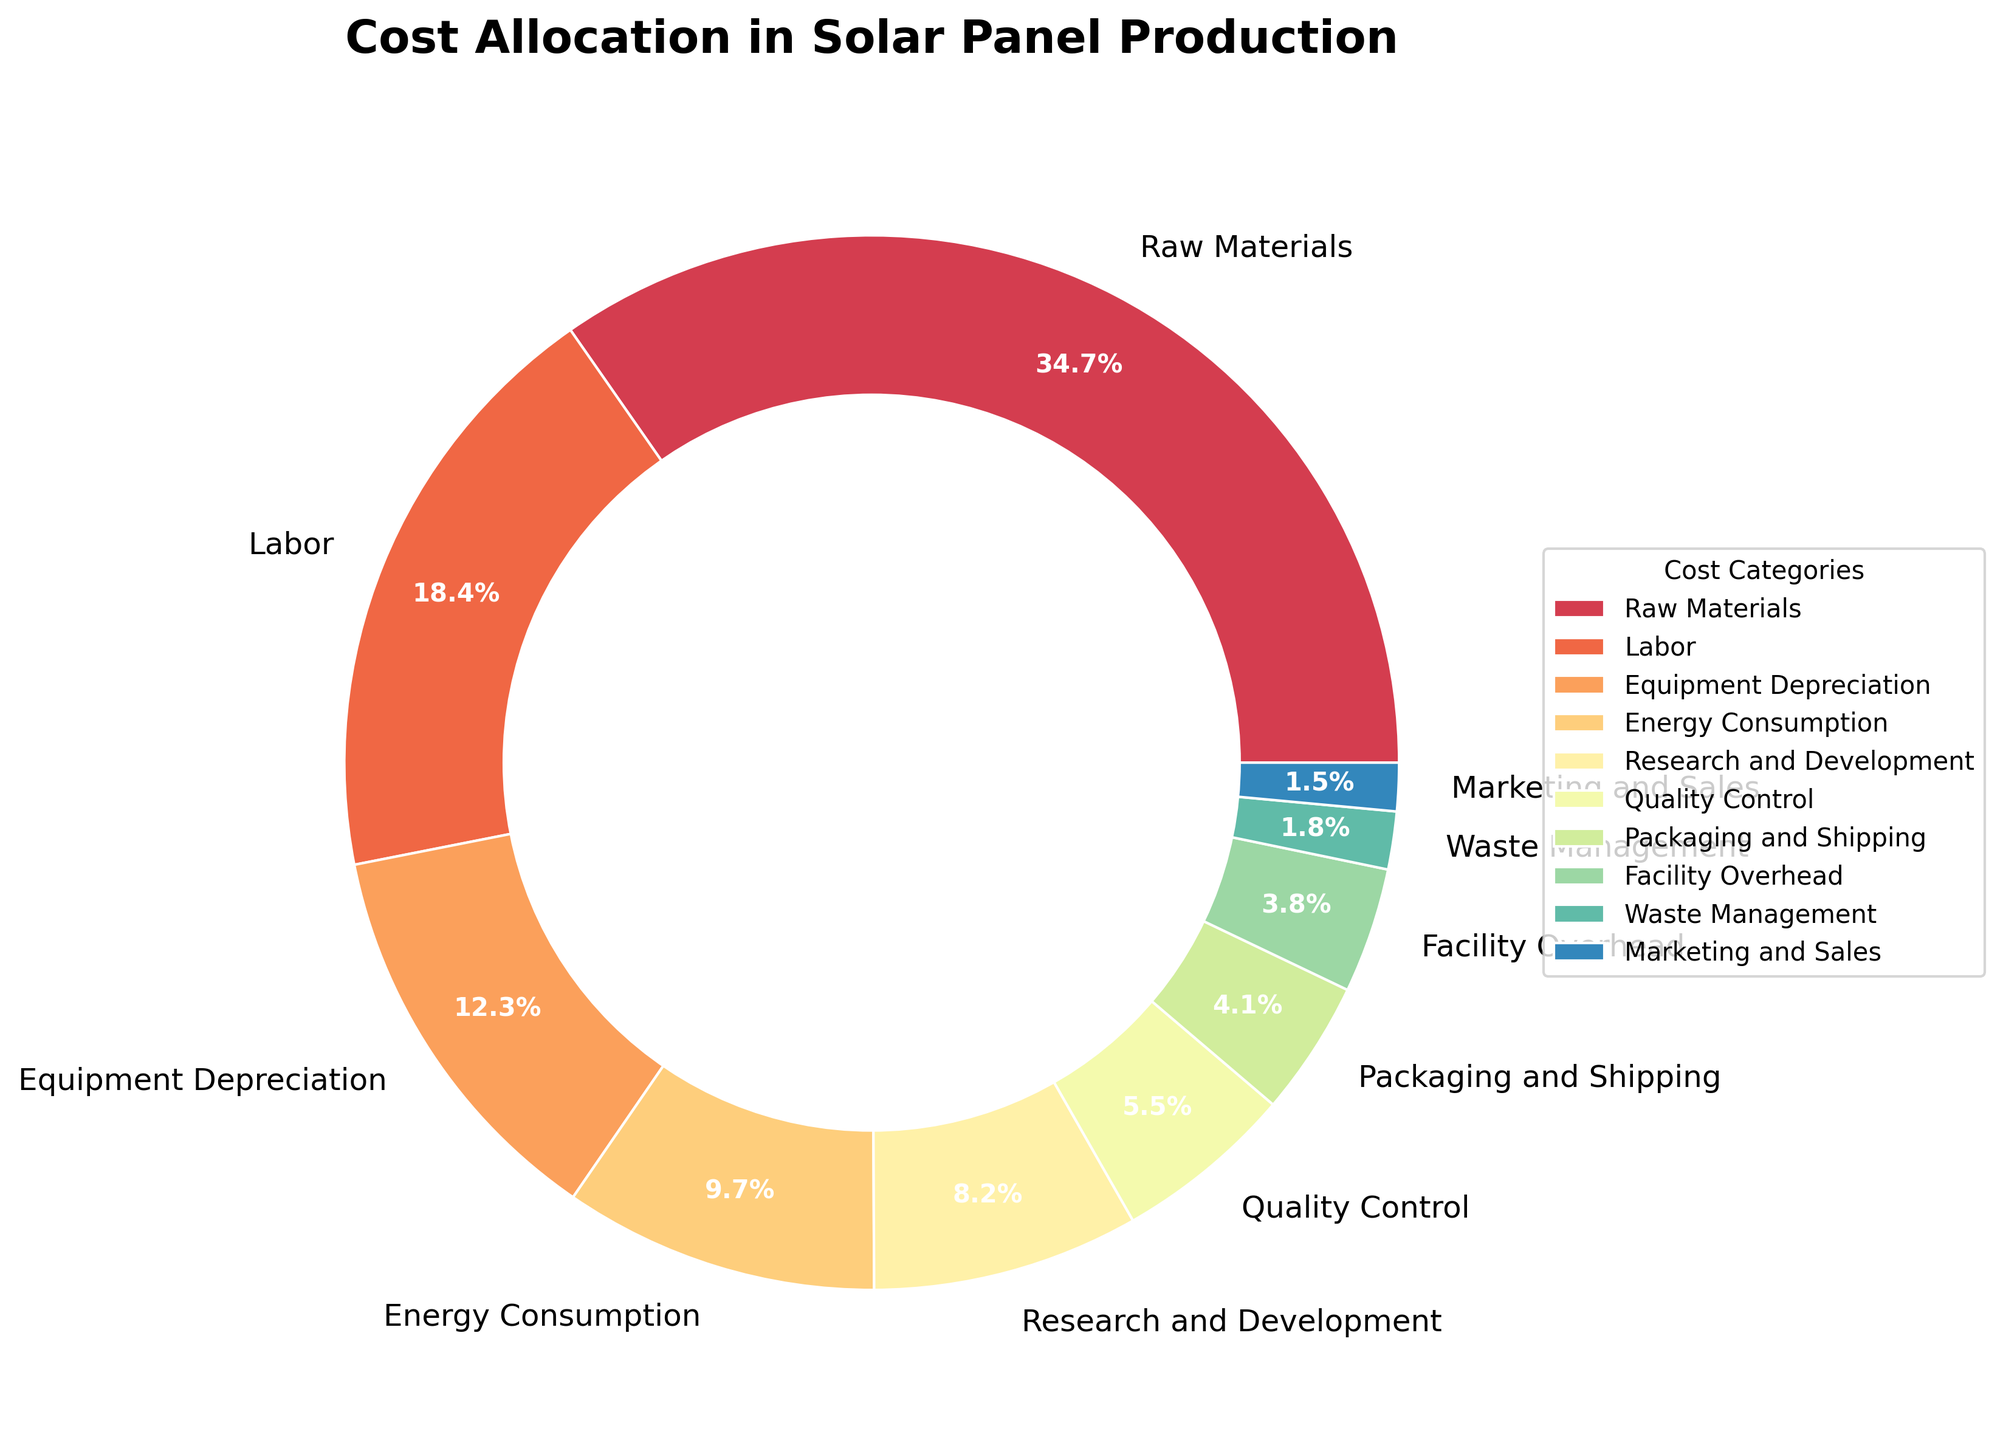What is the largest cost category in solar panel production? The slice representing "Raw Materials" is the largest in the pie chart. Its label indicates that it accounts for 35.2% of the total cost.
Answer: Raw Materials Which cost category has the smallest allocation? The slice labeled "Marketing and Sales" is the smallest, representing only 1.5% of the total cost.
Answer: Marketing and Sales What is the combined percentage of "Labor" and "Energy Consumption"? From the pie chart, "Labor" is 18.7% and "Energy Consumption" is 9.8%. Adding these two percentages gives 18.7 + 9.8 = 28.5%.
Answer: 28.5% How much more is spent on "Research and Development" compared to "Waste Management"? The chart shows "Research and Development" at 8.3% and "Waste Management" at 1.8%. The difference is 8.3 - 1.8 = 6.5%.
Answer: 6.5% Are "Quality Control" and "Packaging and Shipping" together greater than "Labor"? "Quality Control" is 5.6% and "Packaging and Shipping" is 4.2%. Together they make 5.6 + 4.2 = 9.8%. "Labor" alone is 18.7%. Therefore, together they are not greater than "Labor".
Answer: No What is the difference in percentage between the highest and lowest cost categories? The highest cost category, "Raw Materials," is 35.2%, and the lowest, "Marketing and Sales," is 1.5%. The difference is 35.2 - 1.5 = 33.7%.
Answer: 33.7% Which cost categories have percentages greater than 10%? From the pie chart, "Raw Materials" (35.2%), "Labor" (18.7%), and "Equipment Depreciation" (12.5%) all have percentages greater than 10%.
Answer: Raw Materials, Labor, Equipment Depreciation How much more does "Energy Consumption" cost than "Facility Overhead"? "Energy Consumption" is 9.8% and "Facility Overhead" is 3.9%. The difference is 9.8 - 3.9 = 5.9%.
Answer: 5.9% Is the sum of "Quality Control" and "Packaging and Shipping" costs equal to "Energy Consumption"? "Quality Control" is 5.6% and "Packaging and Shipping" is 4.2%. Their sum is 5.6 + 4.2 = 9.8%, which is exactly the same as "Energy Consumption" at 9.8%.
Answer: Yes 